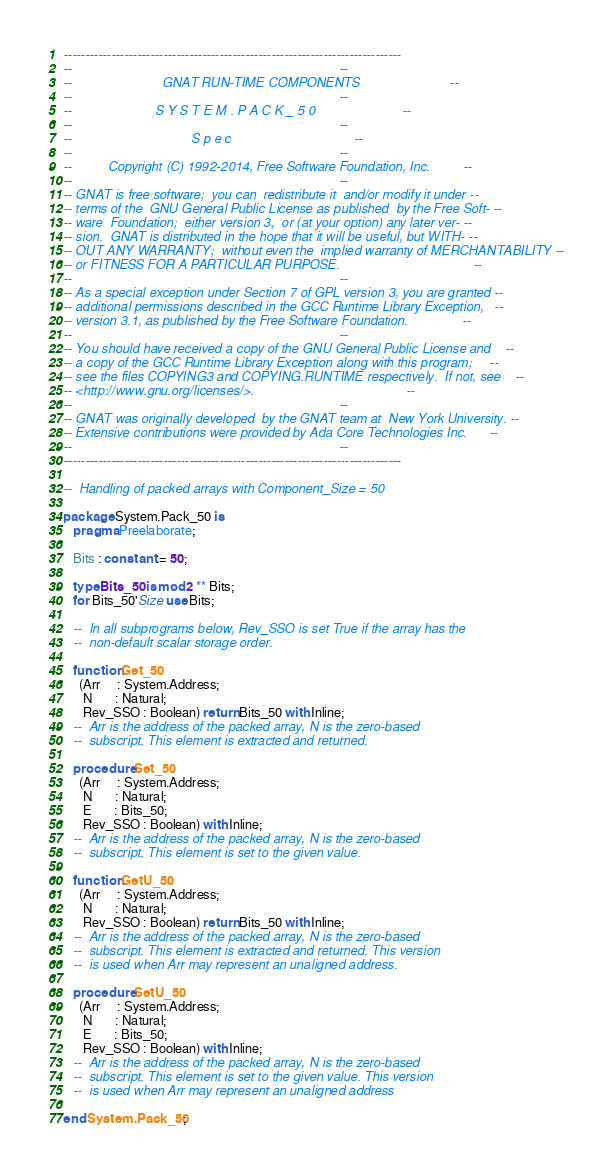<code> <loc_0><loc_0><loc_500><loc_500><_Ada_>------------------------------------------------------------------------------
--                                                                          --
--                         GNAT RUN-TIME COMPONENTS                         --
--                                                                          --
--                       S Y S T E M . P A C K _ 5 0                        --
--                                                                          --
--                                 S p e c                                  --
--                                                                          --
--          Copyright (C) 1992-2014, Free Software Foundation, Inc.         --
--                                                                          --
-- GNAT is free software;  you can  redistribute it  and/or modify it under --
-- terms of the  GNU General Public License as published  by the Free Soft- --
-- ware  Foundation;  either version 3,  or (at your option) any later ver- --
-- sion.  GNAT is distributed in the hope that it will be useful, but WITH- --
-- OUT ANY WARRANTY;  without even the  implied warranty of MERCHANTABILITY --
-- or FITNESS FOR A PARTICULAR PURPOSE.                                     --
--                                                                          --
-- As a special exception under Section 7 of GPL version 3, you are granted --
-- additional permissions described in the GCC Runtime Library Exception,   --
-- version 3.1, as published by the Free Software Foundation.               --
--                                                                          --
-- You should have received a copy of the GNU General Public License and    --
-- a copy of the GCC Runtime Library Exception along with this program;     --
-- see the files COPYING3 and COPYING.RUNTIME respectively.  If not, see    --
-- <http://www.gnu.org/licenses/>.                                          --
--                                                                          --
-- GNAT was originally developed  by the GNAT team at  New York University. --
-- Extensive contributions were provided by Ada Core Technologies Inc.      --
--                                                                          --
------------------------------------------------------------------------------

--  Handling of packed arrays with Component_Size = 50

package System.Pack_50 is
   pragma Preelaborate;

   Bits : constant := 50;

   type Bits_50 is mod 2 ** Bits;
   for Bits_50'Size use Bits;

   --  In all subprograms below, Rev_SSO is set True if the array has the
   --  non-default scalar storage order.

   function Get_50
     (Arr     : System.Address;
      N       : Natural;
      Rev_SSO : Boolean) return Bits_50 with Inline;
   --  Arr is the address of the packed array, N is the zero-based
   --  subscript. This element is extracted and returned.

   procedure Set_50
     (Arr     : System.Address;
      N       : Natural;
      E       : Bits_50;
      Rev_SSO : Boolean) with Inline;
   --  Arr is the address of the packed array, N is the zero-based
   --  subscript. This element is set to the given value.

   function GetU_50
     (Arr     : System.Address;
      N       : Natural;
      Rev_SSO : Boolean) return Bits_50 with Inline;
   --  Arr is the address of the packed array, N is the zero-based
   --  subscript. This element is extracted and returned. This version
   --  is used when Arr may represent an unaligned address.

   procedure SetU_50
     (Arr     : System.Address;
      N       : Natural;
      E       : Bits_50;
      Rev_SSO : Boolean) with Inline;
   --  Arr is the address of the packed array, N is the zero-based
   --  subscript. This element is set to the given value. This version
   --  is used when Arr may represent an unaligned address

end System.Pack_50;
</code> 